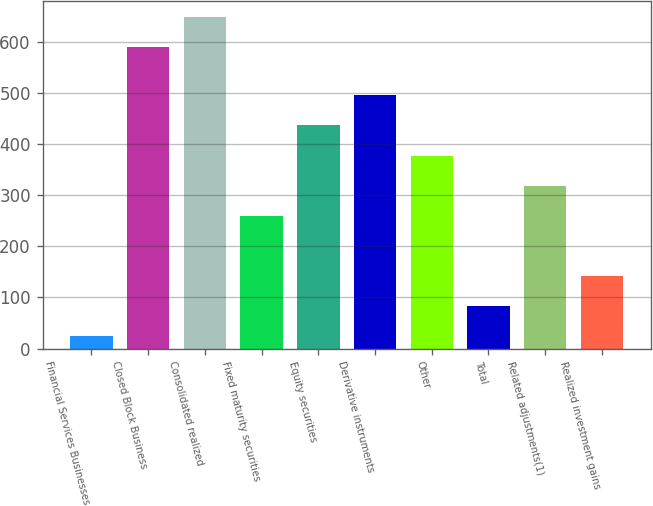Convert chart. <chart><loc_0><loc_0><loc_500><loc_500><bar_chart><fcel>Financial Services Businesses<fcel>Closed Block Business<fcel>Consolidated realized<fcel>Fixed maturity securities<fcel>Equity securities<fcel>Derivative instruments<fcel>Other<fcel>Total<fcel>Related adjustments(1)<fcel>Realized investment gains<nl><fcel>24<fcel>589<fcel>647.9<fcel>259.6<fcel>436.3<fcel>495.2<fcel>377.4<fcel>82.9<fcel>318.5<fcel>141.8<nl></chart> 